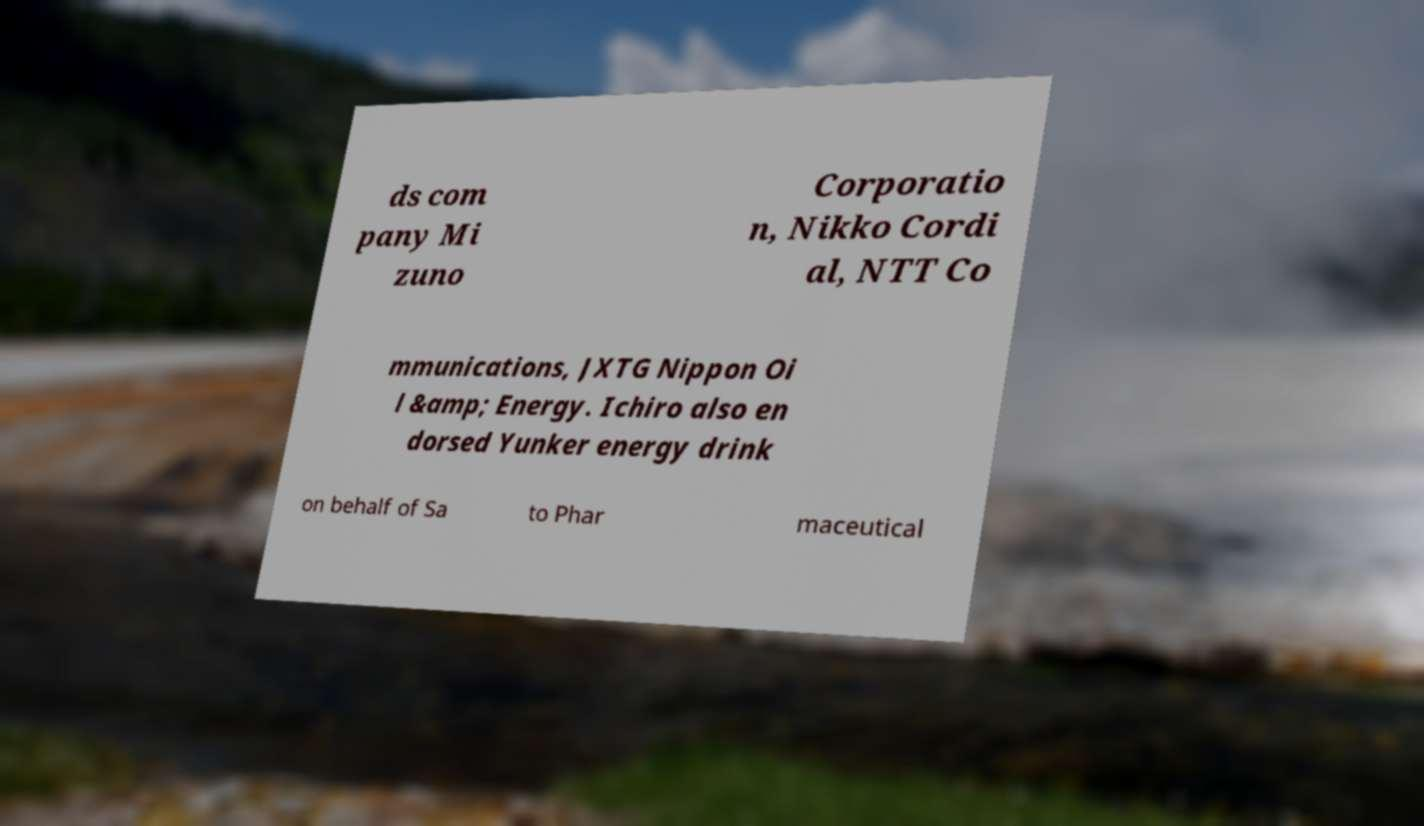There's text embedded in this image that I need extracted. Can you transcribe it verbatim? ds com pany Mi zuno Corporatio n, Nikko Cordi al, NTT Co mmunications, JXTG Nippon Oi l &amp; Energy. Ichiro also en dorsed Yunker energy drink on behalf of Sa to Phar maceutical 